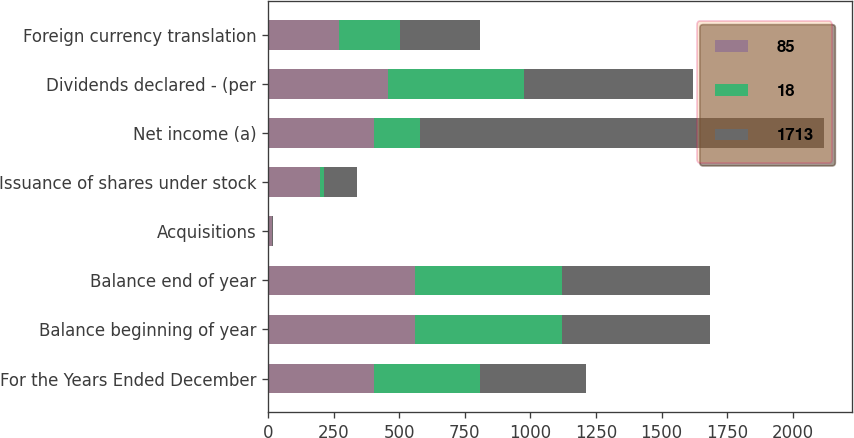Convert chart to OTSL. <chart><loc_0><loc_0><loc_500><loc_500><stacked_bar_chart><ecel><fcel>For the Years Ended December<fcel>Balance beginning of year<fcel>Balance end of year<fcel>Acquisitions<fcel>Issuance of shares under stock<fcel>Net income (a)<fcel>Dividends declared - (per<fcel>Foreign currency translation<nl><fcel>85<fcel>404<fcel>561<fcel>561<fcel>15<fcel>200<fcel>404<fcel>457<fcel>271<nl><fcel>18<fcel>404<fcel>561<fcel>561<fcel>1<fcel>14<fcel>176<fcel>518<fcel>234<nl><fcel>1713<fcel>404<fcel>561<fcel>561<fcel>2<fcel>127<fcel>1540<fcel>644<fcel>302<nl></chart> 